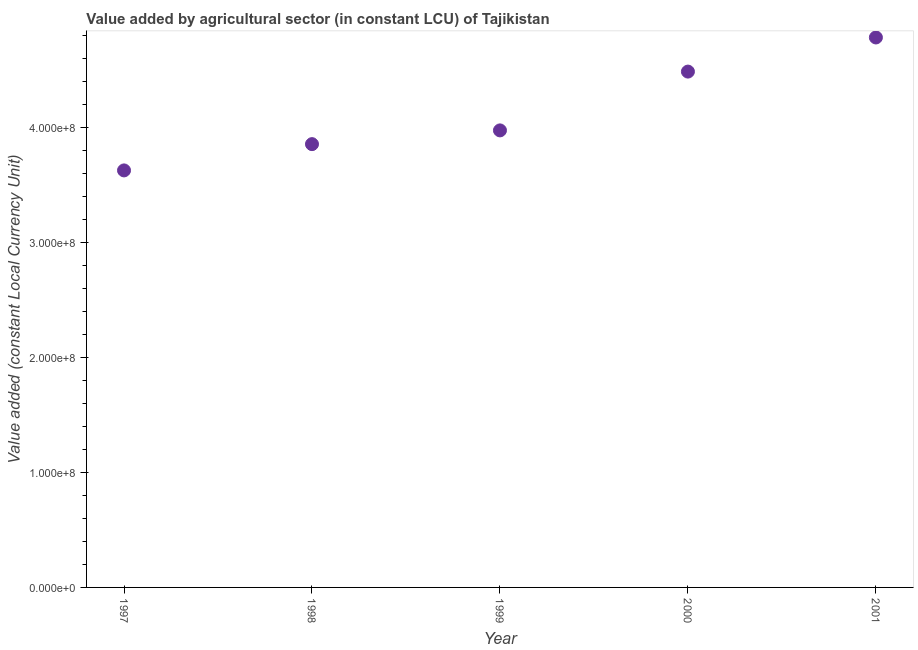What is the value added by agriculture sector in 1998?
Offer a terse response. 3.86e+08. Across all years, what is the maximum value added by agriculture sector?
Provide a short and direct response. 4.78e+08. Across all years, what is the minimum value added by agriculture sector?
Offer a terse response. 3.63e+08. In which year was the value added by agriculture sector minimum?
Provide a short and direct response. 1997. What is the sum of the value added by agriculture sector?
Offer a terse response. 2.07e+09. What is the difference between the value added by agriculture sector in 1998 and 2000?
Provide a short and direct response. -6.31e+07. What is the average value added by agriculture sector per year?
Provide a short and direct response. 4.15e+08. What is the median value added by agriculture sector?
Provide a succinct answer. 3.98e+08. Do a majority of the years between 2001 and 1997 (inclusive) have value added by agriculture sector greater than 140000000 LCU?
Offer a very short reply. Yes. What is the ratio of the value added by agriculture sector in 1998 to that in 2001?
Your answer should be very brief. 0.81. Is the difference between the value added by agriculture sector in 1997 and 2000 greater than the difference between any two years?
Your response must be concise. No. What is the difference between the highest and the second highest value added by agriculture sector?
Your answer should be compact. 2.97e+07. Is the sum of the value added by agriculture sector in 1997 and 1999 greater than the maximum value added by agriculture sector across all years?
Ensure brevity in your answer.  Yes. What is the difference between the highest and the lowest value added by agriculture sector?
Give a very brief answer. 1.16e+08. How many dotlines are there?
Make the answer very short. 1. What is the difference between two consecutive major ticks on the Y-axis?
Provide a succinct answer. 1.00e+08. Are the values on the major ticks of Y-axis written in scientific E-notation?
Keep it short and to the point. Yes. What is the title of the graph?
Offer a very short reply. Value added by agricultural sector (in constant LCU) of Tajikistan. What is the label or title of the X-axis?
Offer a terse response. Year. What is the label or title of the Y-axis?
Your response must be concise. Value added (constant Local Currency Unit). What is the Value added (constant Local Currency Unit) in 1997?
Offer a very short reply. 3.63e+08. What is the Value added (constant Local Currency Unit) in 1998?
Make the answer very short. 3.86e+08. What is the Value added (constant Local Currency Unit) in 1999?
Make the answer very short. 3.98e+08. What is the Value added (constant Local Currency Unit) in 2000?
Make the answer very short. 4.49e+08. What is the Value added (constant Local Currency Unit) in 2001?
Your answer should be very brief. 4.78e+08. What is the difference between the Value added (constant Local Currency Unit) in 1997 and 1998?
Give a very brief answer. -2.29e+07. What is the difference between the Value added (constant Local Currency Unit) in 1997 and 1999?
Your response must be concise. -3.48e+07. What is the difference between the Value added (constant Local Currency Unit) in 1997 and 2000?
Your answer should be compact. -8.60e+07. What is the difference between the Value added (constant Local Currency Unit) in 1997 and 2001?
Make the answer very short. -1.16e+08. What is the difference between the Value added (constant Local Currency Unit) in 1998 and 1999?
Give a very brief answer. -1.20e+07. What is the difference between the Value added (constant Local Currency Unit) in 1998 and 2000?
Make the answer very short. -6.31e+07. What is the difference between the Value added (constant Local Currency Unit) in 1998 and 2001?
Keep it short and to the point. -9.28e+07. What is the difference between the Value added (constant Local Currency Unit) in 1999 and 2000?
Your answer should be compact. -5.12e+07. What is the difference between the Value added (constant Local Currency Unit) in 1999 and 2001?
Your answer should be very brief. -8.08e+07. What is the difference between the Value added (constant Local Currency Unit) in 2000 and 2001?
Provide a succinct answer. -2.97e+07. What is the ratio of the Value added (constant Local Currency Unit) in 1997 to that in 1998?
Your answer should be compact. 0.94. What is the ratio of the Value added (constant Local Currency Unit) in 1997 to that in 1999?
Give a very brief answer. 0.91. What is the ratio of the Value added (constant Local Currency Unit) in 1997 to that in 2000?
Make the answer very short. 0.81. What is the ratio of the Value added (constant Local Currency Unit) in 1997 to that in 2001?
Ensure brevity in your answer.  0.76. What is the ratio of the Value added (constant Local Currency Unit) in 1998 to that in 1999?
Ensure brevity in your answer.  0.97. What is the ratio of the Value added (constant Local Currency Unit) in 1998 to that in 2000?
Offer a very short reply. 0.86. What is the ratio of the Value added (constant Local Currency Unit) in 1998 to that in 2001?
Give a very brief answer. 0.81. What is the ratio of the Value added (constant Local Currency Unit) in 1999 to that in 2000?
Your response must be concise. 0.89. What is the ratio of the Value added (constant Local Currency Unit) in 1999 to that in 2001?
Offer a terse response. 0.83. What is the ratio of the Value added (constant Local Currency Unit) in 2000 to that in 2001?
Make the answer very short. 0.94. 